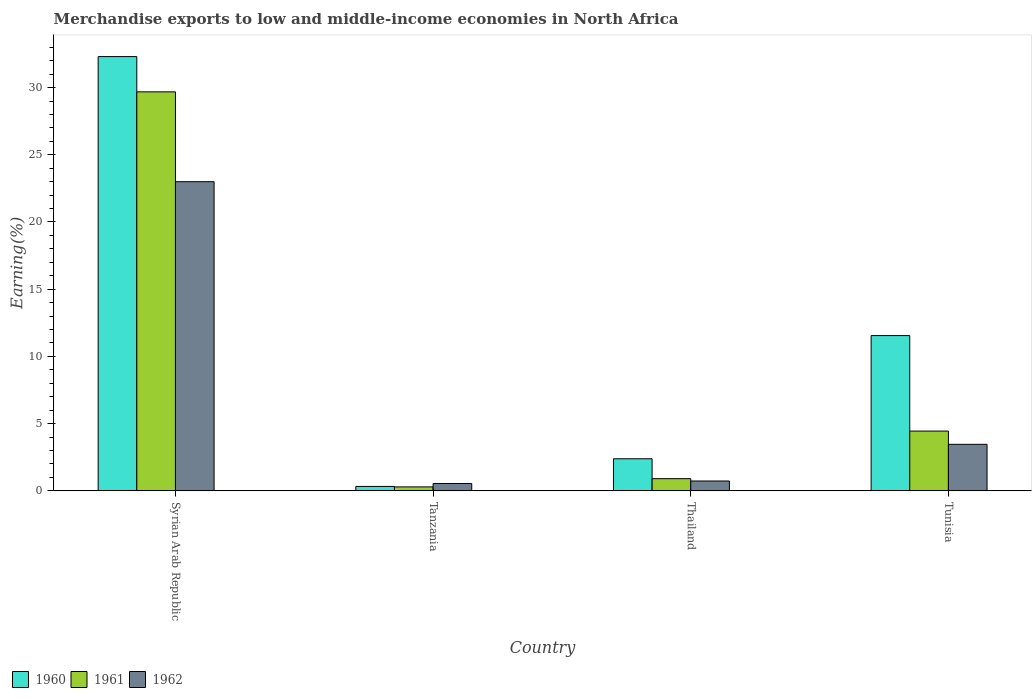Are the number of bars on each tick of the X-axis equal?
Your response must be concise. Yes. How many bars are there on the 2nd tick from the right?
Your answer should be compact. 3. What is the label of the 2nd group of bars from the left?
Ensure brevity in your answer.  Tanzania. In how many cases, is the number of bars for a given country not equal to the number of legend labels?
Ensure brevity in your answer.  0. What is the percentage of amount earned from merchandise exports in 1960 in Thailand?
Keep it short and to the point. 2.38. Across all countries, what is the maximum percentage of amount earned from merchandise exports in 1961?
Offer a terse response. 29.68. Across all countries, what is the minimum percentage of amount earned from merchandise exports in 1960?
Offer a very short reply. 0.32. In which country was the percentage of amount earned from merchandise exports in 1961 maximum?
Provide a succinct answer. Syrian Arab Republic. In which country was the percentage of amount earned from merchandise exports in 1960 minimum?
Give a very brief answer. Tanzania. What is the total percentage of amount earned from merchandise exports in 1961 in the graph?
Offer a very short reply. 35.32. What is the difference between the percentage of amount earned from merchandise exports in 1960 in Syrian Arab Republic and that in Tanzania?
Offer a very short reply. 31.98. What is the difference between the percentage of amount earned from merchandise exports in 1961 in Tanzania and the percentage of amount earned from merchandise exports in 1962 in Tunisia?
Keep it short and to the point. -3.17. What is the average percentage of amount earned from merchandise exports in 1961 per country?
Provide a short and direct response. 8.83. What is the difference between the percentage of amount earned from merchandise exports of/in 1960 and percentage of amount earned from merchandise exports of/in 1962 in Tunisia?
Offer a terse response. 8.09. In how many countries, is the percentage of amount earned from merchandise exports in 1962 greater than 20 %?
Provide a short and direct response. 1. What is the ratio of the percentage of amount earned from merchandise exports in 1961 in Thailand to that in Tunisia?
Ensure brevity in your answer.  0.2. Is the percentage of amount earned from merchandise exports in 1961 in Syrian Arab Republic less than that in Thailand?
Give a very brief answer. No. Is the difference between the percentage of amount earned from merchandise exports in 1960 in Syrian Arab Republic and Thailand greater than the difference between the percentage of amount earned from merchandise exports in 1962 in Syrian Arab Republic and Thailand?
Provide a short and direct response. Yes. What is the difference between the highest and the second highest percentage of amount earned from merchandise exports in 1961?
Give a very brief answer. -3.54. What is the difference between the highest and the lowest percentage of amount earned from merchandise exports in 1960?
Offer a very short reply. 31.98. In how many countries, is the percentage of amount earned from merchandise exports in 1962 greater than the average percentage of amount earned from merchandise exports in 1962 taken over all countries?
Give a very brief answer. 1. What does the 2nd bar from the left in Tanzania represents?
Ensure brevity in your answer.  1961. What does the 1st bar from the right in Thailand represents?
Ensure brevity in your answer.  1962. How many bars are there?
Your response must be concise. 12. Are all the bars in the graph horizontal?
Your response must be concise. No. What is the difference between two consecutive major ticks on the Y-axis?
Your answer should be very brief. 5. Does the graph contain any zero values?
Make the answer very short. No. Does the graph contain grids?
Your answer should be very brief. No. Where does the legend appear in the graph?
Your response must be concise. Bottom left. What is the title of the graph?
Give a very brief answer. Merchandise exports to low and middle-income economies in North Africa. Does "2007" appear as one of the legend labels in the graph?
Keep it short and to the point. No. What is the label or title of the X-axis?
Provide a short and direct response. Country. What is the label or title of the Y-axis?
Offer a very short reply. Earning(%). What is the Earning(%) in 1960 in Syrian Arab Republic?
Keep it short and to the point. 32.31. What is the Earning(%) of 1961 in Syrian Arab Republic?
Your answer should be compact. 29.68. What is the Earning(%) in 1962 in Syrian Arab Republic?
Your answer should be very brief. 23. What is the Earning(%) in 1960 in Tanzania?
Provide a succinct answer. 0.32. What is the Earning(%) of 1961 in Tanzania?
Provide a short and direct response. 0.29. What is the Earning(%) in 1962 in Tanzania?
Ensure brevity in your answer.  0.54. What is the Earning(%) in 1960 in Thailand?
Your answer should be very brief. 2.38. What is the Earning(%) in 1961 in Thailand?
Offer a terse response. 0.9. What is the Earning(%) of 1962 in Thailand?
Keep it short and to the point. 0.73. What is the Earning(%) of 1960 in Tunisia?
Your answer should be compact. 11.55. What is the Earning(%) in 1961 in Tunisia?
Your response must be concise. 4.44. What is the Earning(%) of 1962 in Tunisia?
Give a very brief answer. 3.46. Across all countries, what is the maximum Earning(%) in 1960?
Your answer should be compact. 32.31. Across all countries, what is the maximum Earning(%) of 1961?
Give a very brief answer. 29.68. Across all countries, what is the maximum Earning(%) of 1962?
Offer a terse response. 23. Across all countries, what is the minimum Earning(%) of 1960?
Give a very brief answer. 0.32. Across all countries, what is the minimum Earning(%) in 1961?
Provide a succinct answer. 0.29. Across all countries, what is the minimum Earning(%) of 1962?
Offer a terse response. 0.54. What is the total Earning(%) in 1960 in the graph?
Give a very brief answer. 46.56. What is the total Earning(%) in 1961 in the graph?
Give a very brief answer. 35.32. What is the total Earning(%) of 1962 in the graph?
Provide a short and direct response. 27.73. What is the difference between the Earning(%) in 1960 in Syrian Arab Republic and that in Tanzania?
Give a very brief answer. 31.98. What is the difference between the Earning(%) of 1961 in Syrian Arab Republic and that in Tanzania?
Keep it short and to the point. 29.39. What is the difference between the Earning(%) in 1962 in Syrian Arab Republic and that in Tanzania?
Your answer should be compact. 22.46. What is the difference between the Earning(%) of 1960 in Syrian Arab Republic and that in Thailand?
Provide a short and direct response. 29.93. What is the difference between the Earning(%) of 1961 in Syrian Arab Republic and that in Thailand?
Make the answer very short. 28.78. What is the difference between the Earning(%) of 1962 in Syrian Arab Republic and that in Thailand?
Your answer should be compact. 22.27. What is the difference between the Earning(%) in 1960 in Syrian Arab Republic and that in Tunisia?
Your answer should be very brief. 20.76. What is the difference between the Earning(%) of 1961 in Syrian Arab Republic and that in Tunisia?
Provide a short and direct response. 25.24. What is the difference between the Earning(%) in 1962 in Syrian Arab Republic and that in Tunisia?
Provide a short and direct response. 19.54. What is the difference between the Earning(%) of 1960 in Tanzania and that in Thailand?
Your answer should be very brief. -2.06. What is the difference between the Earning(%) in 1961 in Tanzania and that in Thailand?
Give a very brief answer. -0.61. What is the difference between the Earning(%) in 1962 in Tanzania and that in Thailand?
Your answer should be very brief. -0.19. What is the difference between the Earning(%) in 1960 in Tanzania and that in Tunisia?
Offer a very short reply. -11.22. What is the difference between the Earning(%) of 1961 in Tanzania and that in Tunisia?
Give a very brief answer. -4.15. What is the difference between the Earning(%) in 1962 in Tanzania and that in Tunisia?
Make the answer very short. -2.91. What is the difference between the Earning(%) in 1960 in Thailand and that in Tunisia?
Offer a terse response. -9.17. What is the difference between the Earning(%) in 1961 in Thailand and that in Tunisia?
Offer a very short reply. -3.54. What is the difference between the Earning(%) in 1962 in Thailand and that in Tunisia?
Ensure brevity in your answer.  -2.73. What is the difference between the Earning(%) in 1960 in Syrian Arab Republic and the Earning(%) in 1961 in Tanzania?
Keep it short and to the point. 32.02. What is the difference between the Earning(%) of 1960 in Syrian Arab Republic and the Earning(%) of 1962 in Tanzania?
Your response must be concise. 31.77. What is the difference between the Earning(%) in 1961 in Syrian Arab Republic and the Earning(%) in 1962 in Tanzania?
Provide a succinct answer. 29.14. What is the difference between the Earning(%) of 1960 in Syrian Arab Republic and the Earning(%) of 1961 in Thailand?
Your answer should be very brief. 31.41. What is the difference between the Earning(%) of 1960 in Syrian Arab Republic and the Earning(%) of 1962 in Thailand?
Your answer should be compact. 31.58. What is the difference between the Earning(%) in 1961 in Syrian Arab Republic and the Earning(%) in 1962 in Thailand?
Give a very brief answer. 28.95. What is the difference between the Earning(%) of 1960 in Syrian Arab Republic and the Earning(%) of 1961 in Tunisia?
Your answer should be compact. 27.87. What is the difference between the Earning(%) in 1960 in Syrian Arab Republic and the Earning(%) in 1962 in Tunisia?
Provide a succinct answer. 28.85. What is the difference between the Earning(%) of 1961 in Syrian Arab Republic and the Earning(%) of 1962 in Tunisia?
Make the answer very short. 26.23. What is the difference between the Earning(%) of 1960 in Tanzania and the Earning(%) of 1961 in Thailand?
Ensure brevity in your answer.  -0.58. What is the difference between the Earning(%) in 1960 in Tanzania and the Earning(%) in 1962 in Thailand?
Offer a terse response. -0.41. What is the difference between the Earning(%) in 1961 in Tanzania and the Earning(%) in 1962 in Thailand?
Provide a succinct answer. -0.44. What is the difference between the Earning(%) of 1960 in Tanzania and the Earning(%) of 1961 in Tunisia?
Ensure brevity in your answer.  -4.12. What is the difference between the Earning(%) of 1960 in Tanzania and the Earning(%) of 1962 in Tunisia?
Keep it short and to the point. -3.13. What is the difference between the Earning(%) of 1961 in Tanzania and the Earning(%) of 1962 in Tunisia?
Your response must be concise. -3.17. What is the difference between the Earning(%) in 1960 in Thailand and the Earning(%) in 1961 in Tunisia?
Provide a short and direct response. -2.06. What is the difference between the Earning(%) of 1960 in Thailand and the Earning(%) of 1962 in Tunisia?
Keep it short and to the point. -1.07. What is the difference between the Earning(%) of 1961 in Thailand and the Earning(%) of 1962 in Tunisia?
Keep it short and to the point. -2.56. What is the average Earning(%) of 1960 per country?
Your answer should be compact. 11.64. What is the average Earning(%) in 1961 per country?
Offer a very short reply. 8.83. What is the average Earning(%) in 1962 per country?
Your answer should be very brief. 6.93. What is the difference between the Earning(%) in 1960 and Earning(%) in 1961 in Syrian Arab Republic?
Your answer should be compact. 2.62. What is the difference between the Earning(%) in 1960 and Earning(%) in 1962 in Syrian Arab Republic?
Offer a very short reply. 9.31. What is the difference between the Earning(%) of 1961 and Earning(%) of 1962 in Syrian Arab Republic?
Ensure brevity in your answer.  6.68. What is the difference between the Earning(%) in 1960 and Earning(%) in 1961 in Tanzania?
Ensure brevity in your answer.  0.03. What is the difference between the Earning(%) in 1960 and Earning(%) in 1962 in Tanzania?
Offer a terse response. -0.22. What is the difference between the Earning(%) of 1961 and Earning(%) of 1962 in Tanzania?
Offer a terse response. -0.25. What is the difference between the Earning(%) of 1960 and Earning(%) of 1961 in Thailand?
Provide a short and direct response. 1.48. What is the difference between the Earning(%) of 1960 and Earning(%) of 1962 in Thailand?
Offer a very short reply. 1.65. What is the difference between the Earning(%) of 1961 and Earning(%) of 1962 in Thailand?
Make the answer very short. 0.17. What is the difference between the Earning(%) of 1960 and Earning(%) of 1961 in Tunisia?
Your answer should be very brief. 7.11. What is the difference between the Earning(%) in 1960 and Earning(%) in 1962 in Tunisia?
Your answer should be compact. 8.09. What is the difference between the Earning(%) in 1961 and Earning(%) in 1962 in Tunisia?
Keep it short and to the point. 0.99. What is the ratio of the Earning(%) in 1960 in Syrian Arab Republic to that in Tanzania?
Your response must be concise. 99.64. What is the ratio of the Earning(%) in 1961 in Syrian Arab Republic to that in Tanzania?
Keep it short and to the point. 102.56. What is the ratio of the Earning(%) in 1962 in Syrian Arab Republic to that in Tanzania?
Keep it short and to the point. 42.38. What is the ratio of the Earning(%) in 1960 in Syrian Arab Republic to that in Thailand?
Provide a succinct answer. 13.56. What is the ratio of the Earning(%) of 1961 in Syrian Arab Republic to that in Thailand?
Keep it short and to the point. 32.92. What is the ratio of the Earning(%) of 1962 in Syrian Arab Republic to that in Thailand?
Offer a very short reply. 31.53. What is the ratio of the Earning(%) in 1960 in Syrian Arab Republic to that in Tunisia?
Your response must be concise. 2.8. What is the ratio of the Earning(%) in 1961 in Syrian Arab Republic to that in Tunisia?
Give a very brief answer. 6.68. What is the ratio of the Earning(%) in 1962 in Syrian Arab Republic to that in Tunisia?
Your response must be concise. 6.65. What is the ratio of the Earning(%) in 1960 in Tanzania to that in Thailand?
Ensure brevity in your answer.  0.14. What is the ratio of the Earning(%) of 1961 in Tanzania to that in Thailand?
Make the answer very short. 0.32. What is the ratio of the Earning(%) in 1962 in Tanzania to that in Thailand?
Provide a short and direct response. 0.74. What is the ratio of the Earning(%) in 1960 in Tanzania to that in Tunisia?
Your response must be concise. 0.03. What is the ratio of the Earning(%) in 1961 in Tanzania to that in Tunisia?
Ensure brevity in your answer.  0.07. What is the ratio of the Earning(%) of 1962 in Tanzania to that in Tunisia?
Provide a succinct answer. 0.16. What is the ratio of the Earning(%) of 1960 in Thailand to that in Tunisia?
Your answer should be very brief. 0.21. What is the ratio of the Earning(%) of 1961 in Thailand to that in Tunisia?
Give a very brief answer. 0.2. What is the ratio of the Earning(%) of 1962 in Thailand to that in Tunisia?
Make the answer very short. 0.21. What is the difference between the highest and the second highest Earning(%) of 1960?
Give a very brief answer. 20.76. What is the difference between the highest and the second highest Earning(%) of 1961?
Keep it short and to the point. 25.24. What is the difference between the highest and the second highest Earning(%) in 1962?
Offer a very short reply. 19.54. What is the difference between the highest and the lowest Earning(%) in 1960?
Keep it short and to the point. 31.98. What is the difference between the highest and the lowest Earning(%) in 1961?
Keep it short and to the point. 29.39. What is the difference between the highest and the lowest Earning(%) in 1962?
Make the answer very short. 22.46. 